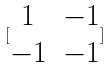Convert formula to latex. <formula><loc_0><loc_0><loc_500><loc_500>[ \begin{matrix} 1 & - 1 \\ - 1 & - 1 \end{matrix} ]</formula> 